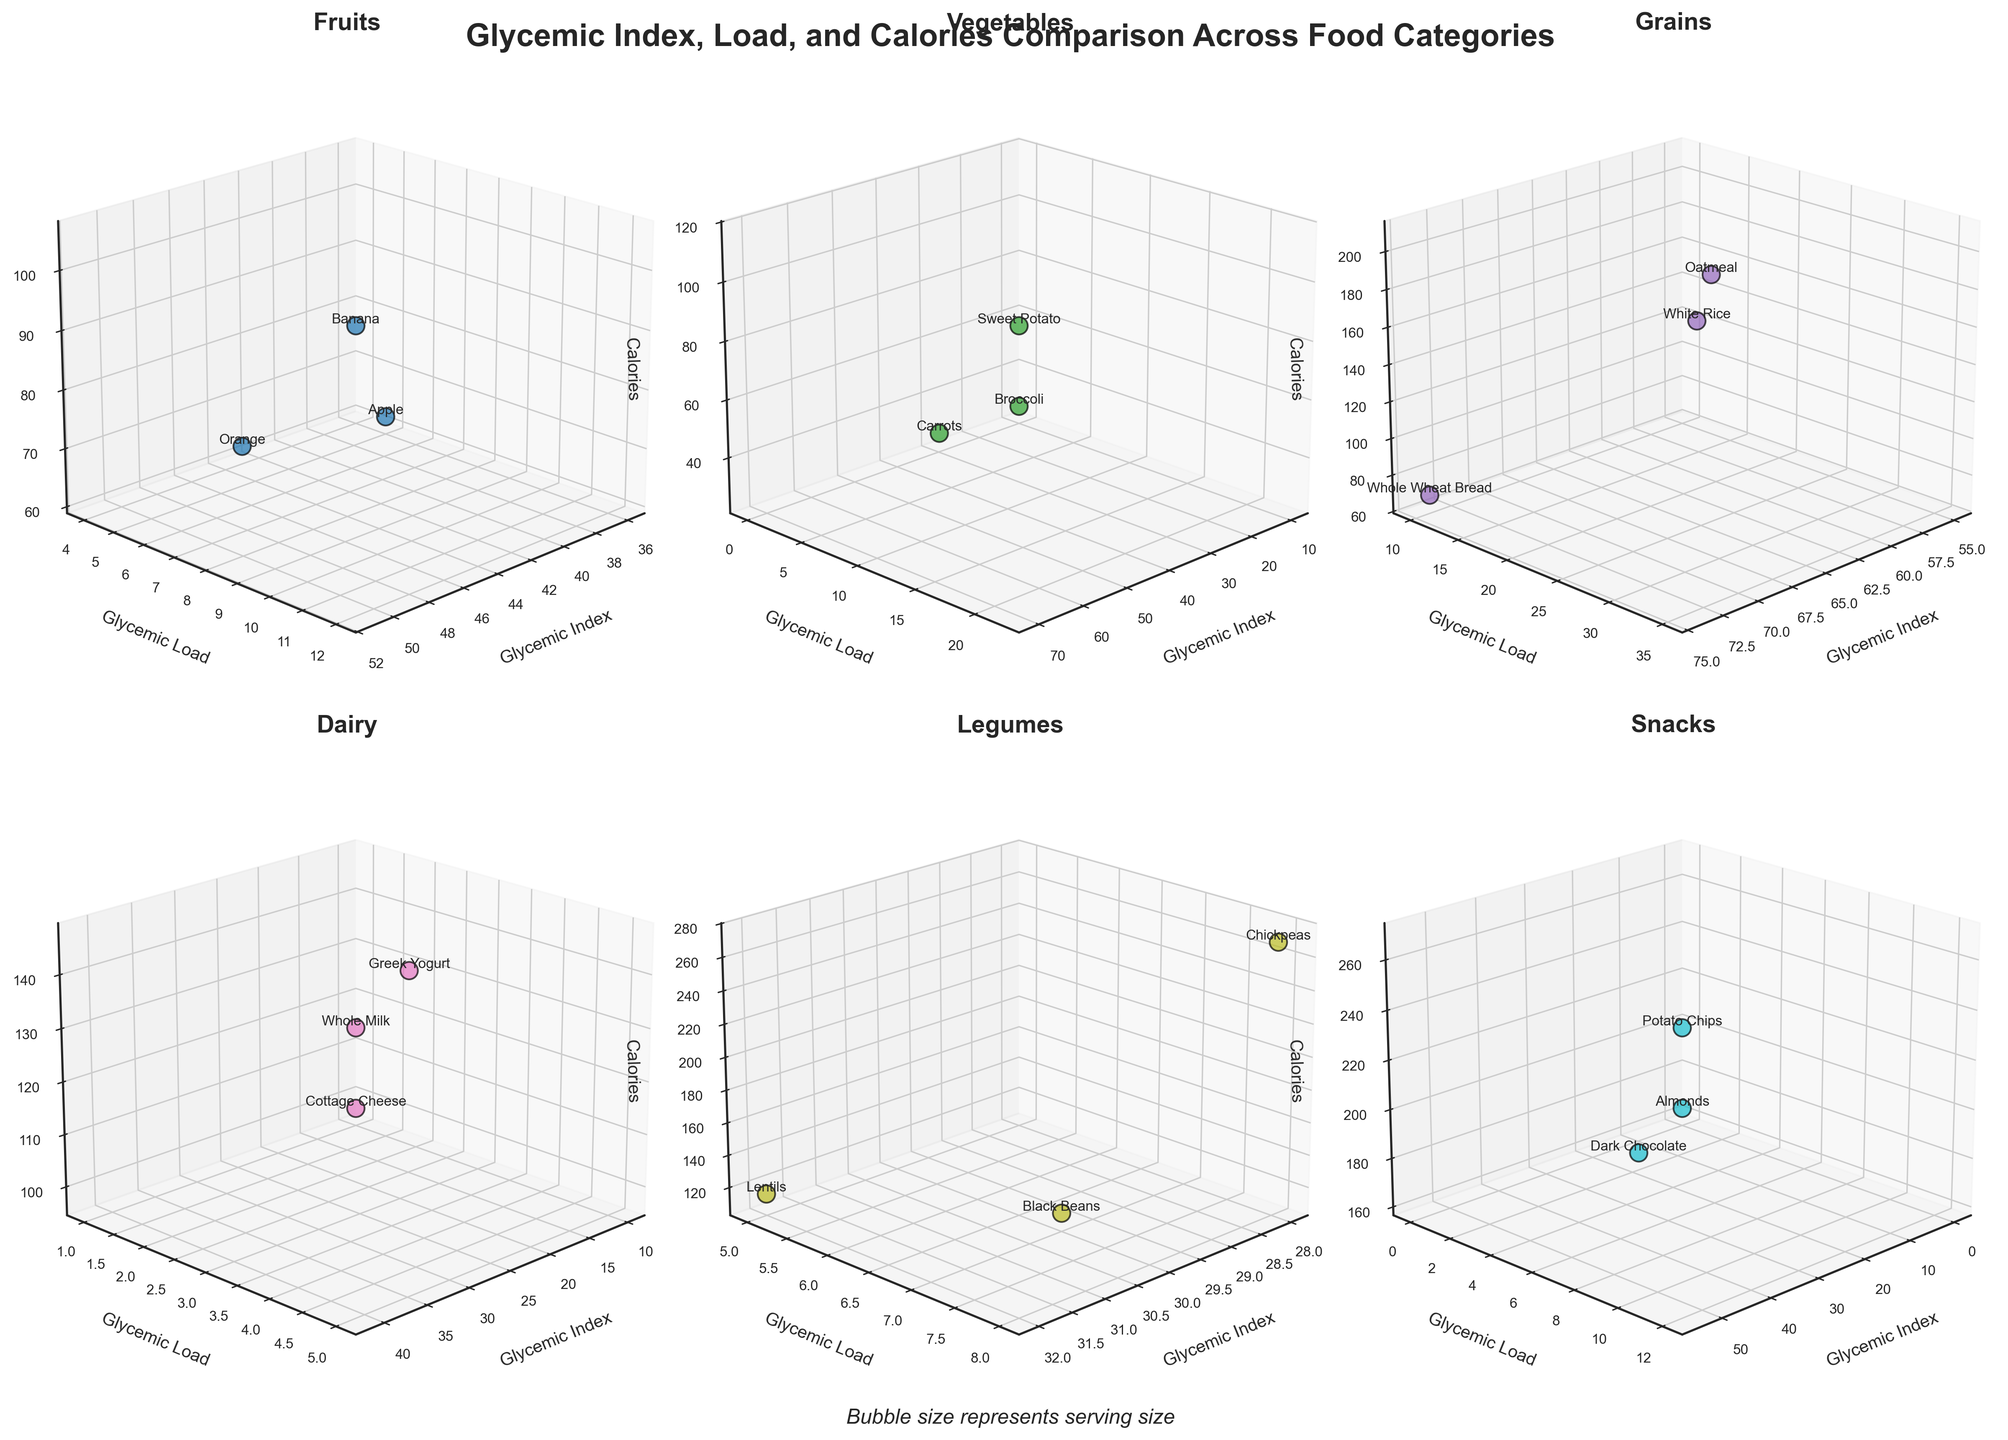What is the highest glycemic index value among the food items in the grains category? By looking at the subplot for the grains category, identify the food item with the highest point on the glycemic index axis. The white rice and whole wheat bread have the highest glycemic index value of 74.
Answer: 74 Which food item has the lowest glycemic load in the dairy category? Check the subplot for the dairy category and find the food item with the lowest point on the glycemic load axis. The food item with the lowest glycemic load is cottage cheese, with a value of 1.
Answer: Cottage Cheese How does the glycemic index of apple compare to that of oatmeal? Locate apples in the fruits category and oatmeal in the grains category, then compare their positions on the glycemic index axis. Apple's glycemic index is lower than oatmeal's, with values of 36 and 55, respectively.
Answer: Apple has a lower glycemic index than oatmeal Which food item in the snacks category has the highest calorie content? Find the point in the snacks category subplot that has the highest value on the calorie axis. The food item with the highest calorie content is potato chips with 267 calories.
Answer: Potato Chips If you want to minimize glycemic load, which vegetable should you choose? Look at the vegetable category subplot and find the food with the lowest point on the glycemic load axis. The food item with the lowest glycemic load is broccoli with a glycemic load of 0.
Answer: Broccoli Is there a food item with a glycemic load higher than 30 in the entire figure? Check all subplots to see if there's any data point with a glycemic load value exceeding 30. The food item with a glycemic load higher than 30 is white rice, which has a glycemic load of 35.
Answer: Yes, White Rice Compare the glycemic index and calorie content of sweet potato and orange. Locate sweet potato in the vegetable category and orange in the fruits category, then compare their glycemic index and calorie values. Sweet potato has a glycemic index of 70 and 114 calories, while orange has a glycemic index of 43 and 62 calories.
Answer: Sweet Potato: GI = 70, Calories = 114; Orange: GI = 43, Calories = 62 Which has a higher glycemic load, chickpeas or black beans? In the legumes category subplot, compare the positions of chickpeas and black beans on the glycemic load axis. Chickpeas have a higher glycemic load of 8 compared to black beans' glycemic load of 7.
Answer: Chickpeas Among fruits, which item balances both low glycemic index and low calorie count the best? Compare the glycemic index and calorie content of all fruit items in the subplot for fruits. Apple has both a low glycemic index of 36 and a low calorie content of 62.
Answer: Apple How does the serving size of whole milk compare to that of Greek yogurt? Check the subplot for the dairy category and examine the bubble sizes for whole milk and Greek yogurt. Whole milk, with a serving size of 250g, has a larger bubble than Greek yogurt, which has a serving size of 150g.
Answer: Whole Milk has a larger serving size 